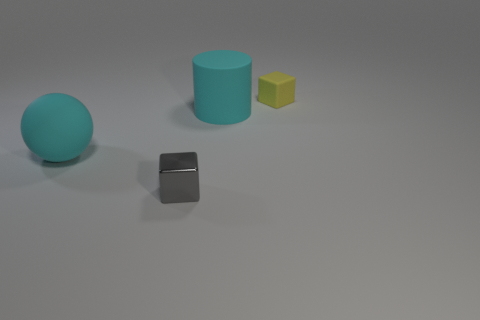Add 1 large cyan objects. How many objects exist? 5 Subtract all spheres. How many objects are left? 3 Subtract 1 spheres. How many spheres are left? 0 Subtract all yellow blocks. Subtract all cyan cylinders. How many blocks are left? 1 Subtract all blue cubes. How many green balls are left? 0 Subtract all large matte spheres. Subtract all tiny blue matte cubes. How many objects are left? 3 Add 2 tiny yellow cubes. How many tiny yellow cubes are left? 3 Add 3 small brown metal objects. How many small brown metal objects exist? 3 Subtract 1 yellow cubes. How many objects are left? 3 